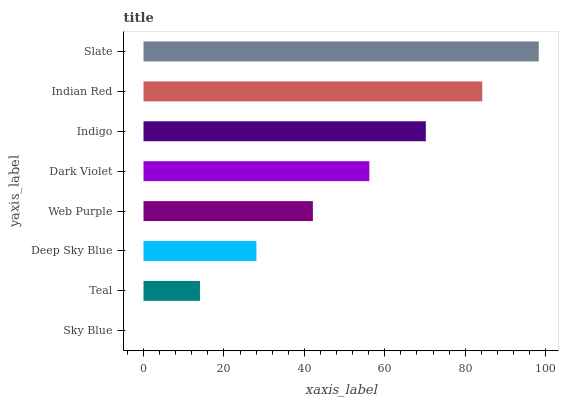Is Sky Blue the minimum?
Answer yes or no. Yes. Is Slate the maximum?
Answer yes or no. Yes. Is Teal the minimum?
Answer yes or no. No. Is Teal the maximum?
Answer yes or no. No. Is Teal greater than Sky Blue?
Answer yes or no. Yes. Is Sky Blue less than Teal?
Answer yes or no. Yes. Is Sky Blue greater than Teal?
Answer yes or no. No. Is Teal less than Sky Blue?
Answer yes or no. No. Is Dark Violet the high median?
Answer yes or no. Yes. Is Web Purple the low median?
Answer yes or no. Yes. Is Indian Red the high median?
Answer yes or no. No. Is Deep Sky Blue the low median?
Answer yes or no. No. 